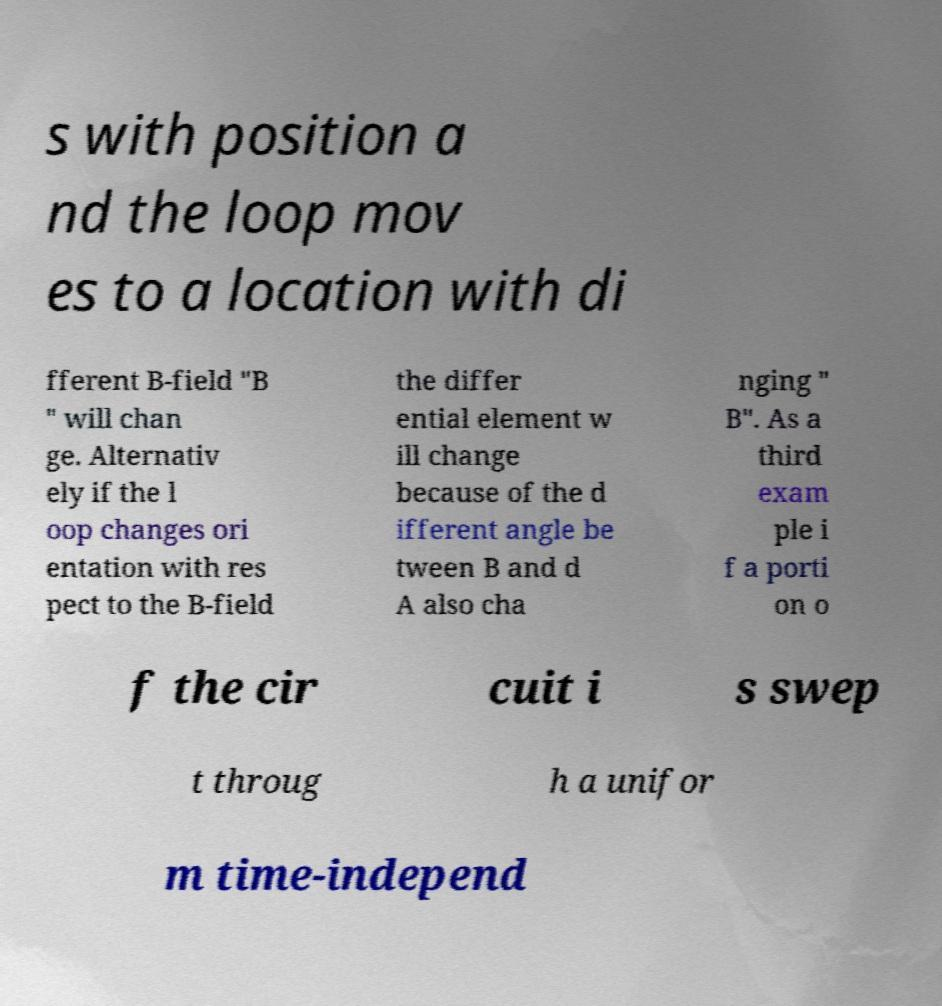For documentation purposes, I need the text within this image transcribed. Could you provide that? s with position a nd the loop mov es to a location with di fferent B-field "B " will chan ge. Alternativ ely if the l oop changes ori entation with res pect to the B-field the differ ential element w ill change because of the d ifferent angle be tween B and d A also cha nging " B". As a third exam ple i f a porti on o f the cir cuit i s swep t throug h a unifor m time-independ 